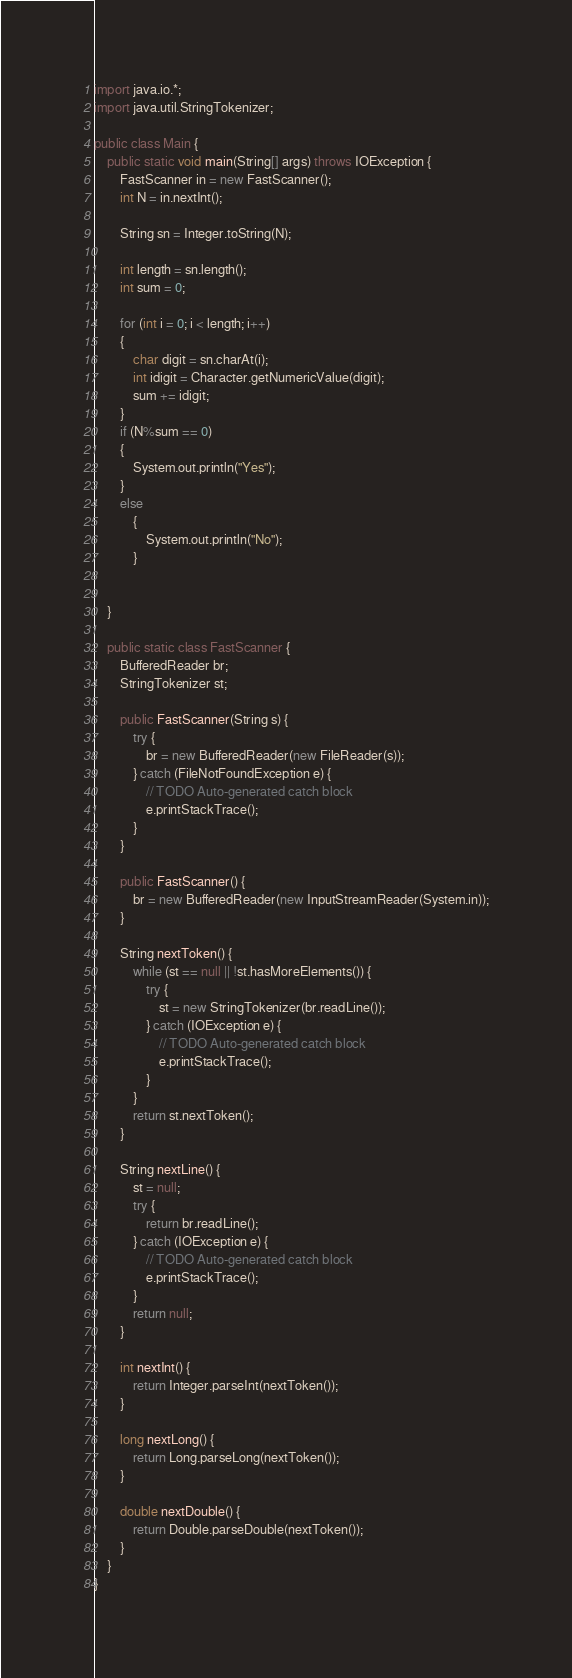<code> <loc_0><loc_0><loc_500><loc_500><_Java_>import java.io.*;
import java.util.StringTokenizer;

public class Main {
    public static void main(String[] args) throws IOException {
        FastScanner in = new FastScanner();
        int N = in.nextInt();

        String sn = Integer.toString(N);

        int length = sn.length();
        int sum = 0;

        for (int i = 0; i < length; i++)
        {
            char digit = sn.charAt(i);
            int idigit = Character.getNumericValue(digit);
            sum += idigit;
        }
        if (N%sum == 0)
        {
            System.out.println("Yes");
        }
        else
            {
                System.out.println("No");
            }


    }

    public static class FastScanner {
        BufferedReader br;
        StringTokenizer st;

        public FastScanner(String s) {
            try {
                br = new BufferedReader(new FileReader(s));
            } catch (FileNotFoundException e) {
                // TODO Auto-generated catch block
                e.printStackTrace();
            }
        }

        public FastScanner() {
            br = new BufferedReader(new InputStreamReader(System.in));
        }

        String nextToken() {
            while (st == null || !st.hasMoreElements()) {
                try {
                    st = new StringTokenizer(br.readLine());
                } catch (IOException e) {
                    // TODO Auto-generated catch block
                    e.printStackTrace();
                }
            }
            return st.nextToken();
        }

        String nextLine() {
            st = null;
            try {
                return br.readLine();
            } catch (IOException e) {
                // TODO Auto-generated catch block
                e.printStackTrace();
            }
            return null;
        }

        int nextInt() {
            return Integer.parseInt(nextToken());
        }

        long nextLong() {
            return Long.parseLong(nextToken());
        }

        double nextDouble() {
            return Double.parseDouble(nextToken());
        }
    }
}
</code> 